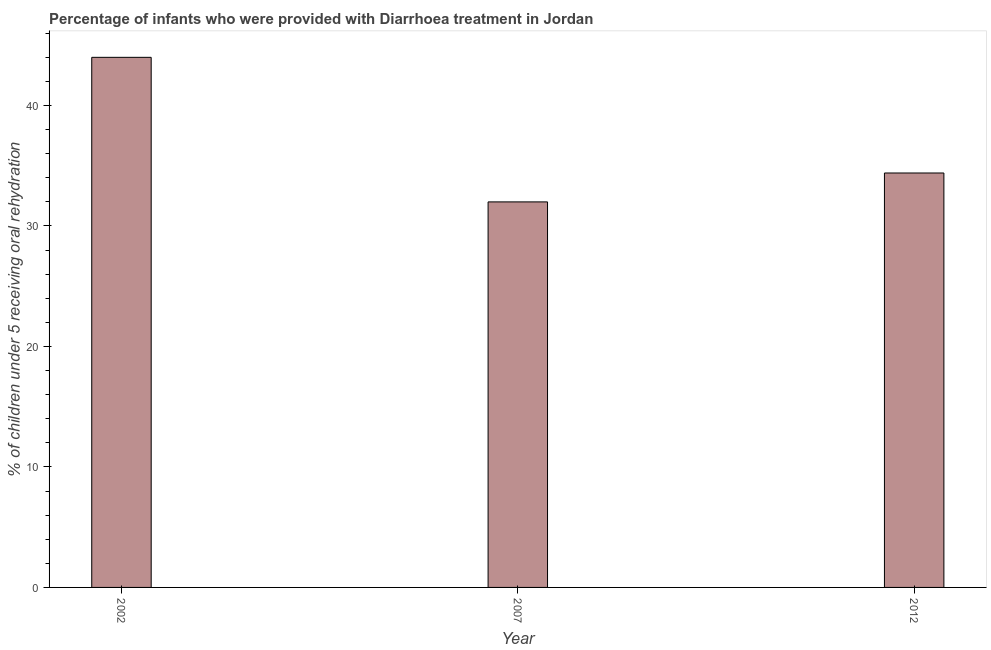Does the graph contain any zero values?
Make the answer very short. No. What is the title of the graph?
Offer a very short reply. Percentage of infants who were provided with Diarrhoea treatment in Jordan. What is the label or title of the X-axis?
Provide a short and direct response. Year. What is the label or title of the Y-axis?
Your answer should be compact. % of children under 5 receiving oral rehydration. In which year was the percentage of children who were provided with treatment diarrhoea minimum?
Your response must be concise. 2007. What is the sum of the percentage of children who were provided with treatment diarrhoea?
Your response must be concise. 110.4. What is the difference between the percentage of children who were provided with treatment diarrhoea in 2002 and 2012?
Offer a very short reply. 9.6. What is the average percentage of children who were provided with treatment diarrhoea per year?
Your answer should be very brief. 36.8. What is the median percentage of children who were provided with treatment diarrhoea?
Your answer should be compact. 34.4. What is the ratio of the percentage of children who were provided with treatment diarrhoea in 2002 to that in 2012?
Provide a succinct answer. 1.28. Is the percentage of children who were provided with treatment diarrhoea in 2002 less than that in 2012?
Give a very brief answer. No. Is the difference between the percentage of children who were provided with treatment diarrhoea in 2007 and 2012 greater than the difference between any two years?
Offer a very short reply. No. What is the difference between the highest and the lowest percentage of children who were provided with treatment diarrhoea?
Your answer should be very brief. 12. In how many years, is the percentage of children who were provided with treatment diarrhoea greater than the average percentage of children who were provided with treatment diarrhoea taken over all years?
Give a very brief answer. 1. How many bars are there?
Give a very brief answer. 3. What is the difference between two consecutive major ticks on the Y-axis?
Provide a succinct answer. 10. Are the values on the major ticks of Y-axis written in scientific E-notation?
Make the answer very short. No. What is the % of children under 5 receiving oral rehydration of 2002?
Your response must be concise. 44. What is the % of children under 5 receiving oral rehydration of 2007?
Keep it short and to the point. 32. What is the % of children under 5 receiving oral rehydration in 2012?
Your answer should be compact. 34.4. What is the difference between the % of children under 5 receiving oral rehydration in 2002 and 2007?
Provide a succinct answer. 12. What is the ratio of the % of children under 5 receiving oral rehydration in 2002 to that in 2007?
Keep it short and to the point. 1.38. What is the ratio of the % of children under 5 receiving oral rehydration in 2002 to that in 2012?
Your answer should be compact. 1.28. 